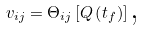Convert formula to latex. <formula><loc_0><loc_0><loc_500><loc_500>v _ { i j } = \Theta _ { i j } \left [ Q \left ( t _ { f } \right ) \right ] \text {,}</formula> 